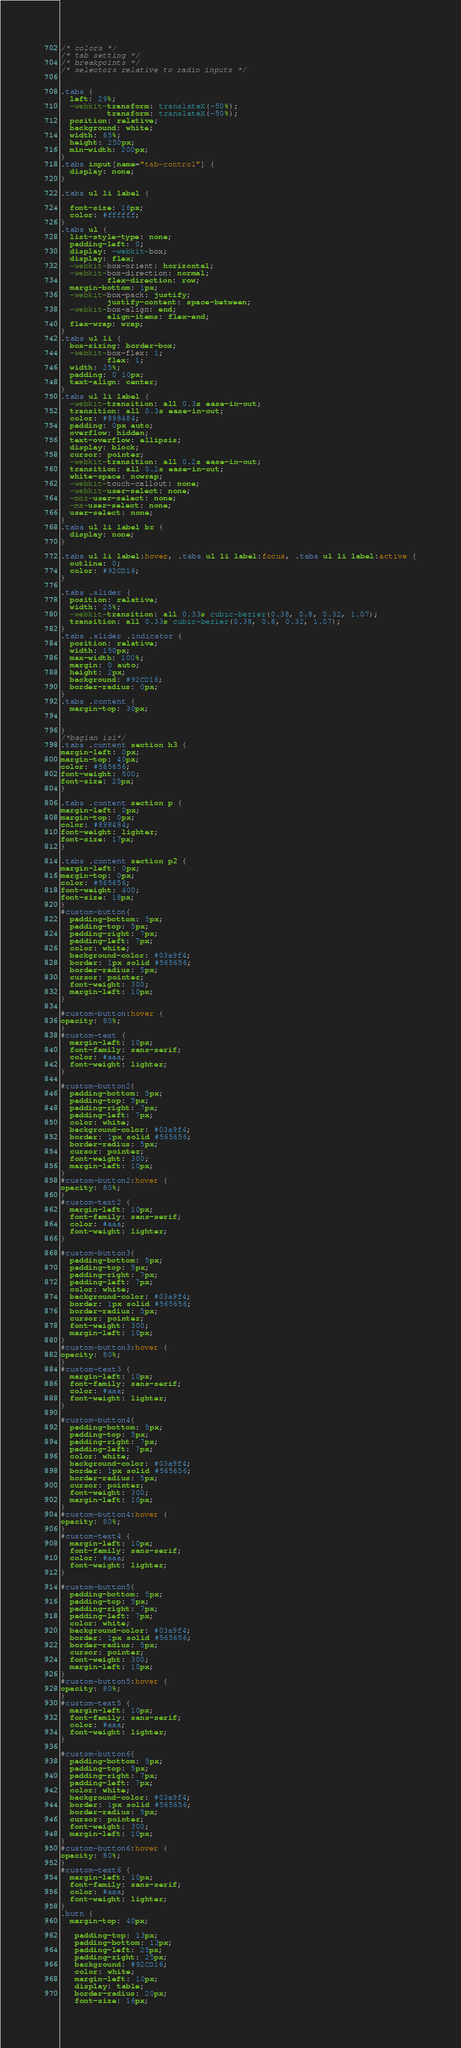<code> <loc_0><loc_0><loc_500><loc_500><_CSS_>
/* colors */
/* tab setting */
/* breakpoints */
/* selectors relative to radio inputs */


.tabs {
  left: 29%;
  -webkit-transform: translateX(-50%);
          transform: translateX(-50%);
  position: relative;
  background: white;
  width: 65%;
  height: 250px;
  min-width: 200px;
}
.tabs input[name="tab-control"] {
  display: none;
}

.tabs ul li label {

  font-size: 16px;
  color: #ffffff;
}
.tabs ul {
  list-style-type: none;
  padding-left: 0;
  display: -webkit-box;
  display: flex;
  -webkit-box-orient: horizontal;
  -webkit-box-direction: normal;
          flex-direction: row;
  margin-bottom: 1px;
  -webkit-box-pack: justify;
          justify-content: space-between;
  -webkit-box-align: end;
          align-items: flex-end;
  flex-wrap: wrap;
}
.tabs ul li {
  box-sizing: border-box;
  -webkit-box-flex: 1;
          flex: 1;
  width: 25%;
  padding: 0 10px;
  text-align: center;
}
.tabs ul li label {
  -webkit-transition: all 0.3s ease-in-out;
  transition: all 0.3s ease-in-out;
  color: #898484;
  padding: 0px auto;
  overflow: hidden;
  text-overflow: ellipsis;
  display: block;
  cursor: pointer;
  -webkit-transition: all 0.2s ease-in-out;
  transition: all 0.2s ease-in-out;
  white-space: nowrap;
  -webkit-touch-callout: none;
  -webkit-user-select: none;
  -moz-user-select: none;
  -ms-user-select: none;
  user-select: none;
}
.tabs ul li label br {
  display: none;
}

.tabs ul li label:hover, .tabs ul li label:focus, .tabs ul li label:active {
  outline: 0;
  color: #92CD16;
}

.tabs .slider {
  position: relative;
  width: 25%;
  -webkit-transition: all 0.33s cubic-bezier(0.38, 0.8, 0.32, 1.07);
  transition: all 0.33s cubic-bezier(0.38, 0.8, 0.32, 1.07);
}
.tabs .slider .indicator {
  position: relative;
  width: 150px;
  max-width: 100%;
  margin: 0 auto;
  height: 2px;
  background: #92CD16;
  border-radius: 0px;
}
.tabs .content {
  margin-top: 30px;


}
/*bagian isi*/
.tabs .content section h3 {
margin-left: 0px;
margin-top: 40px;
color: #565656;
font-weight: 500;
font-size: 25px;
}

.tabs .content section p {
margin-left: 0px;
margin-top: 0px;
color: #898484;
font-weight: lighter;
font-size: 17px;
}

.tabs .content section p2 {
margin-left: 0px;
margin-top: 0px;
color: #565656;
font-weight: 400;
font-size: 18px;
}
#custom-button{
  padding-bottom: 5px;
  padding-top: 5px;
  padding-right: 7px;
  padding-left: 7px;
  color: white;
  background-color: #03a9f4;
  border: 1px solid #565656;
  border-radius: 5px;
  cursor: pointer;
  font-weight: 300;
  margin-left: 10px;
}

#custom-button:hover {
opacity: 80%;
}
#custom-text {
  margin-left: 10px;
  font-family: sans-serif;
  color: #aaa;
  font-weight: lighter;
}

#custom-button2{
  padding-bottom: 5px;
  padding-top: 5px;
  padding-right: 7px;
  padding-left: 7px;
  color: white;
  background-color: #03a9f4;
  border: 1px solid #565656;
  border-radius: 5px;
  cursor: pointer;
  font-weight: 300;
  margin-left: 10px;
}
#custom-button2:hover {
opacity: 80%;
}
#custom-text2 {
  margin-left: 10px;
  font-family: sans-serif;
  color: #aaa;
  font-weight: lighter;
}

#custom-button3{
  padding-bottom: 5px;
  padding-top: 5px;
  padding-right: 7px;
  padding-left: 7px;
  color: white;
  background-color: #03a9f4;
  border: 1px solid #565656;
  border-radius: 5px;
  cursor: pointer;
  font-weight: 300;
  margin-left: 10px;
}
#custom-button3:hover {
opacity: 80%;
}
#custom-text3 {
  margin-left: 10px;
  font-family: sans-serif;
  color: #aaa;
  font-weight: lighter;
}

#custom-button4{
  padding-bottom: 5px;
  padding-top: 5px;
  padding-right: 7px;
  padding-left: 7px;
  color: white;
  background-color: #03a9f4;
  border: 1px solid #565656;
  border-radius: 5px;
  cursor: pointer;
  font-weight: 300;
  margin-left: 10px;
}
#custom-button4:hover {
opacity: 80%;
}
#custom-text4 {
  margin-left: 10px;
  font-family: sans-serif;
  color: #aaa;
  font-weight: lighter;
}

#custom-button5{
  padding-bottom: 5px;
  padding-top: 5px;
  padding-right: 7px;
  padding-left: 7px;
  color: white;
  background-color: #03a9f4;
  border: 1px solid #565656;
  border-radius: 5px;
  cursor: pointer;
  font-weight: 300;
  margin-left: 10px;
}
#custom-button5:hover {
opacity: 80%;
}
#custom-text5 {
  margin-left: 10px;
  font-family: sans-serif;
  color: #aaa;
  font-weight: lighter;
}

#custom-button6{
  padding-bottom: 5px;
  padding-top: 5px;
  padding-right: 7px;
  padding-left: 7px;
  color: white;
  background-color: #03a9f4;
  border: 1px solid #565656;
  border-radius: 5px;
  cursor: pointer;
  font-weight: 300;
  margin-left: 10px;
}
#custom-button6:hover {
opacity: 80%;
}
#custom-text6 {
  margin-left: 10px;
  font-family: sans-serif;
  color: #aaa;
  font-weight: lighter;
}
.butn {
  margin-top: 40px;

   padding-top: 13px;
   padding-bottom: 13px;
   padding-left: 25px;
   padding-right: 25px;
   background: #92CD16;
   color: white;
   margin-left: 10px;
   display: table;
   border-radius: 20px;
   font-size: 16px;</code> 